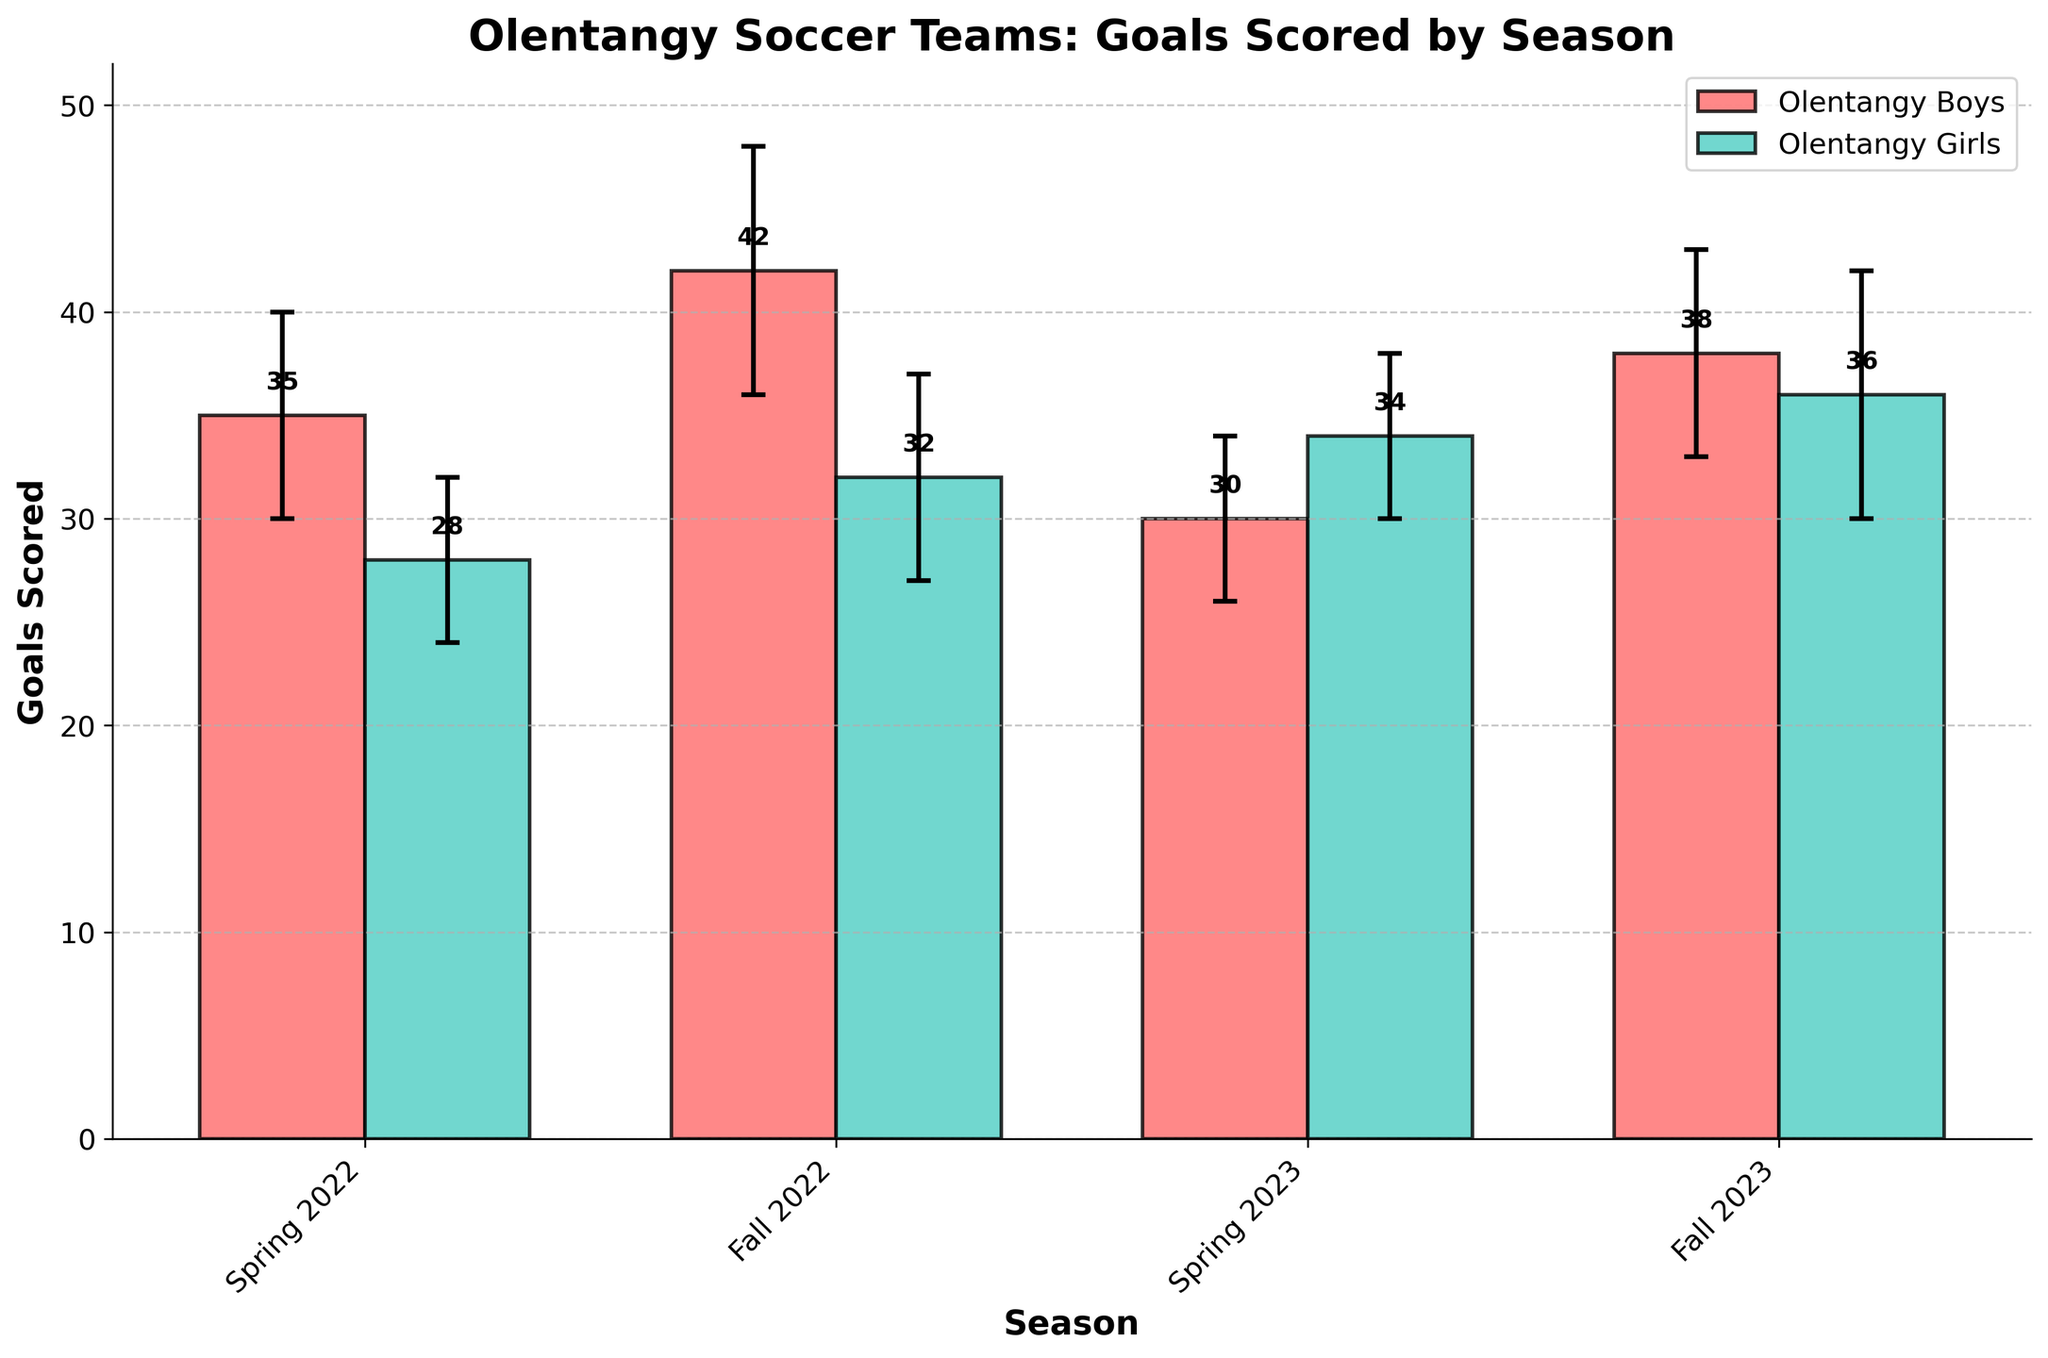What is the title of the plot? The title of the plot is written at the top of the figure.
Answer: Olentangy Soccer Teams: Goals Scored by Season How many seasons are depicted in the plot? The x-axis labels represent different seasons, each tick marks a particular season. There are four such labels.
Answer: Four Which team scored the most goals in a single season and in which season was it? By observing the height of the bars, the tallest bar indicates the highest number of goals by a team in a season. The Olentangy Boys scored the most goals in Fall 2022.
Answer: Olentangy Boys, Fall 2022 What is the color used to represent the Olentangy Girls team? The color used for each team is distinct and is shown in the legend. The Olentangy Girls are represented in teal.
Answer: Teal What are the goals scored by the Olentangy Boys in Spring 2023? Refer to the height of the corresponding bar for the Olentangy Boys' Spring 2023 season which is labeled on the y-axis. The bar reaches up to 30 goals.
Answer: 30 Which team had more variability in goals scored in Fall 2022? Variability is indicated by the length of the error bars. By comparing them, we can see the longer error bar. The Olentangy Boys had more variability in goals scored in Fall 2022.
Answer: Olentangy Boys Which season had the lowest average goals scored by both teams when combined? Sum the goals scored by both teams for each season and compare. Spring 2023 had the lowest combined goals (30 + 34 = 64).
Answer: Spring 2023 In which season did the Olentangy Girls improve their goals scored compared to the previous similar season? Compare the goals scored by the Olentangy Girls in successive seasons. The Olentangy Girls improved from Spring 2022 (28 goals) to Spring 2023 (34 goals) and from Fall 2022 (32 goals) to Fall 2023 (36 goals).
Answer: Spring 2023, Fall 2023 What was the average number of goals scored by the Olentangy Boys across all four seasons displayed? Sum the goals scored in all four seasons and divide by 4. (35 + 42 + 30 + 38) / 4 -> 145 / 4 -> 36.25
Answer: 36.25 How does the highest goals scored by Olentangy Girls compare to the lowest goals scored by Olentangy Boys? The highest goals scored by the Olentangy Girls is 36 (Fall 2023), and the lowest by the Olentangy Boys is 30 (Spring 2023). The highest goals of the Olentangy Girls are greater by 6.
Answer: 36 goals > 30 goals 